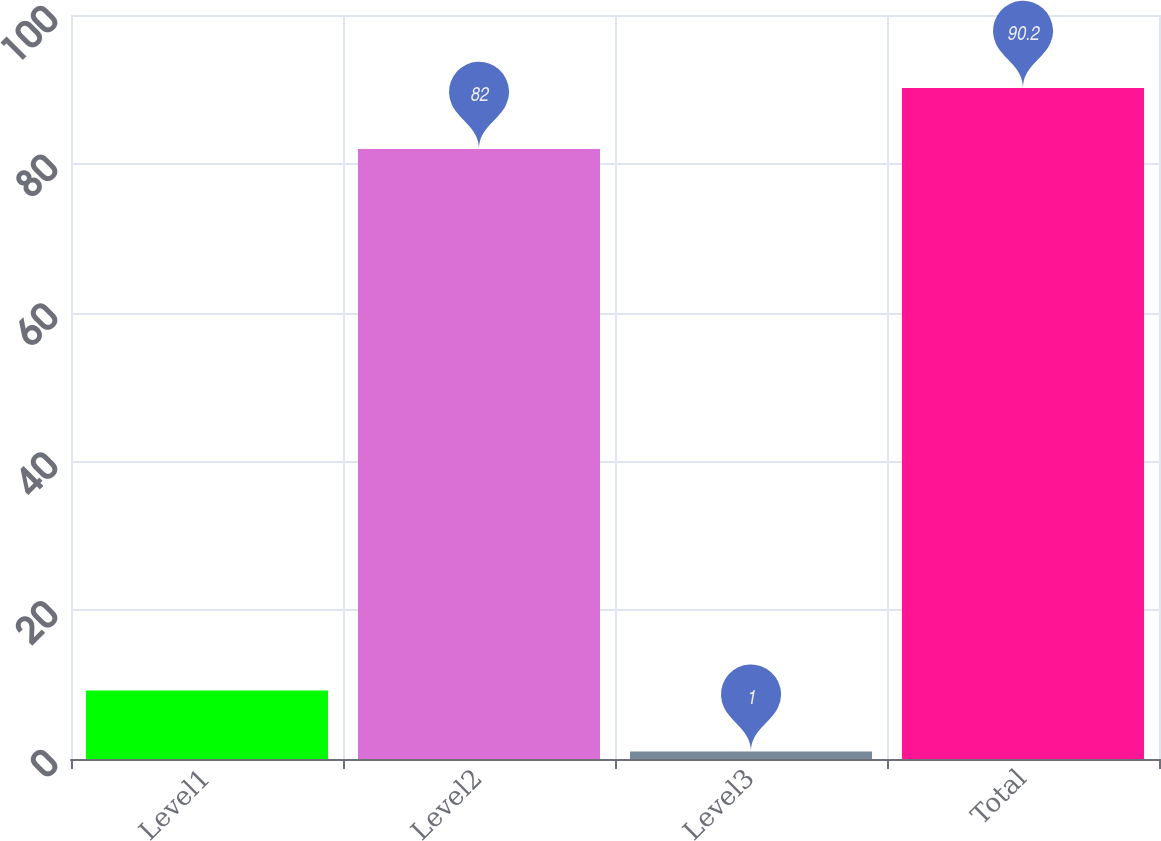<chart> <loc_0><loc_0><loc_500><loc_500><bar_chart><fcel>Level1<fcel>Level2<fcel>Level3<fcel>Total<nl><fcel>9.2<fcel>82<fcel>1<fcel>90.2<nl></chart> 